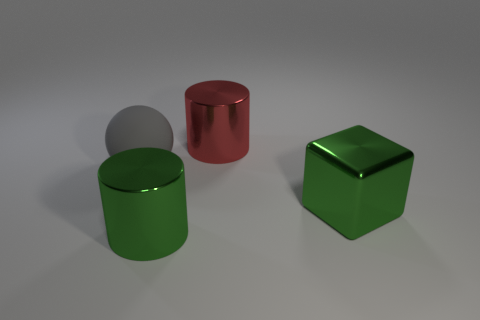Add 4 shiny things. How many objects exist? 8 Subtract all balls. How many objects are left? 3 Subtract all tiny red rubber cylinders. Subtract all large green blocks. How many objects are left? 3 Add 2 matte things. How many matte things are left? 3 Add 1 matte things. How many matte things exist? 2 Subtract 0 cyan spheres. How many objects are left? 4 